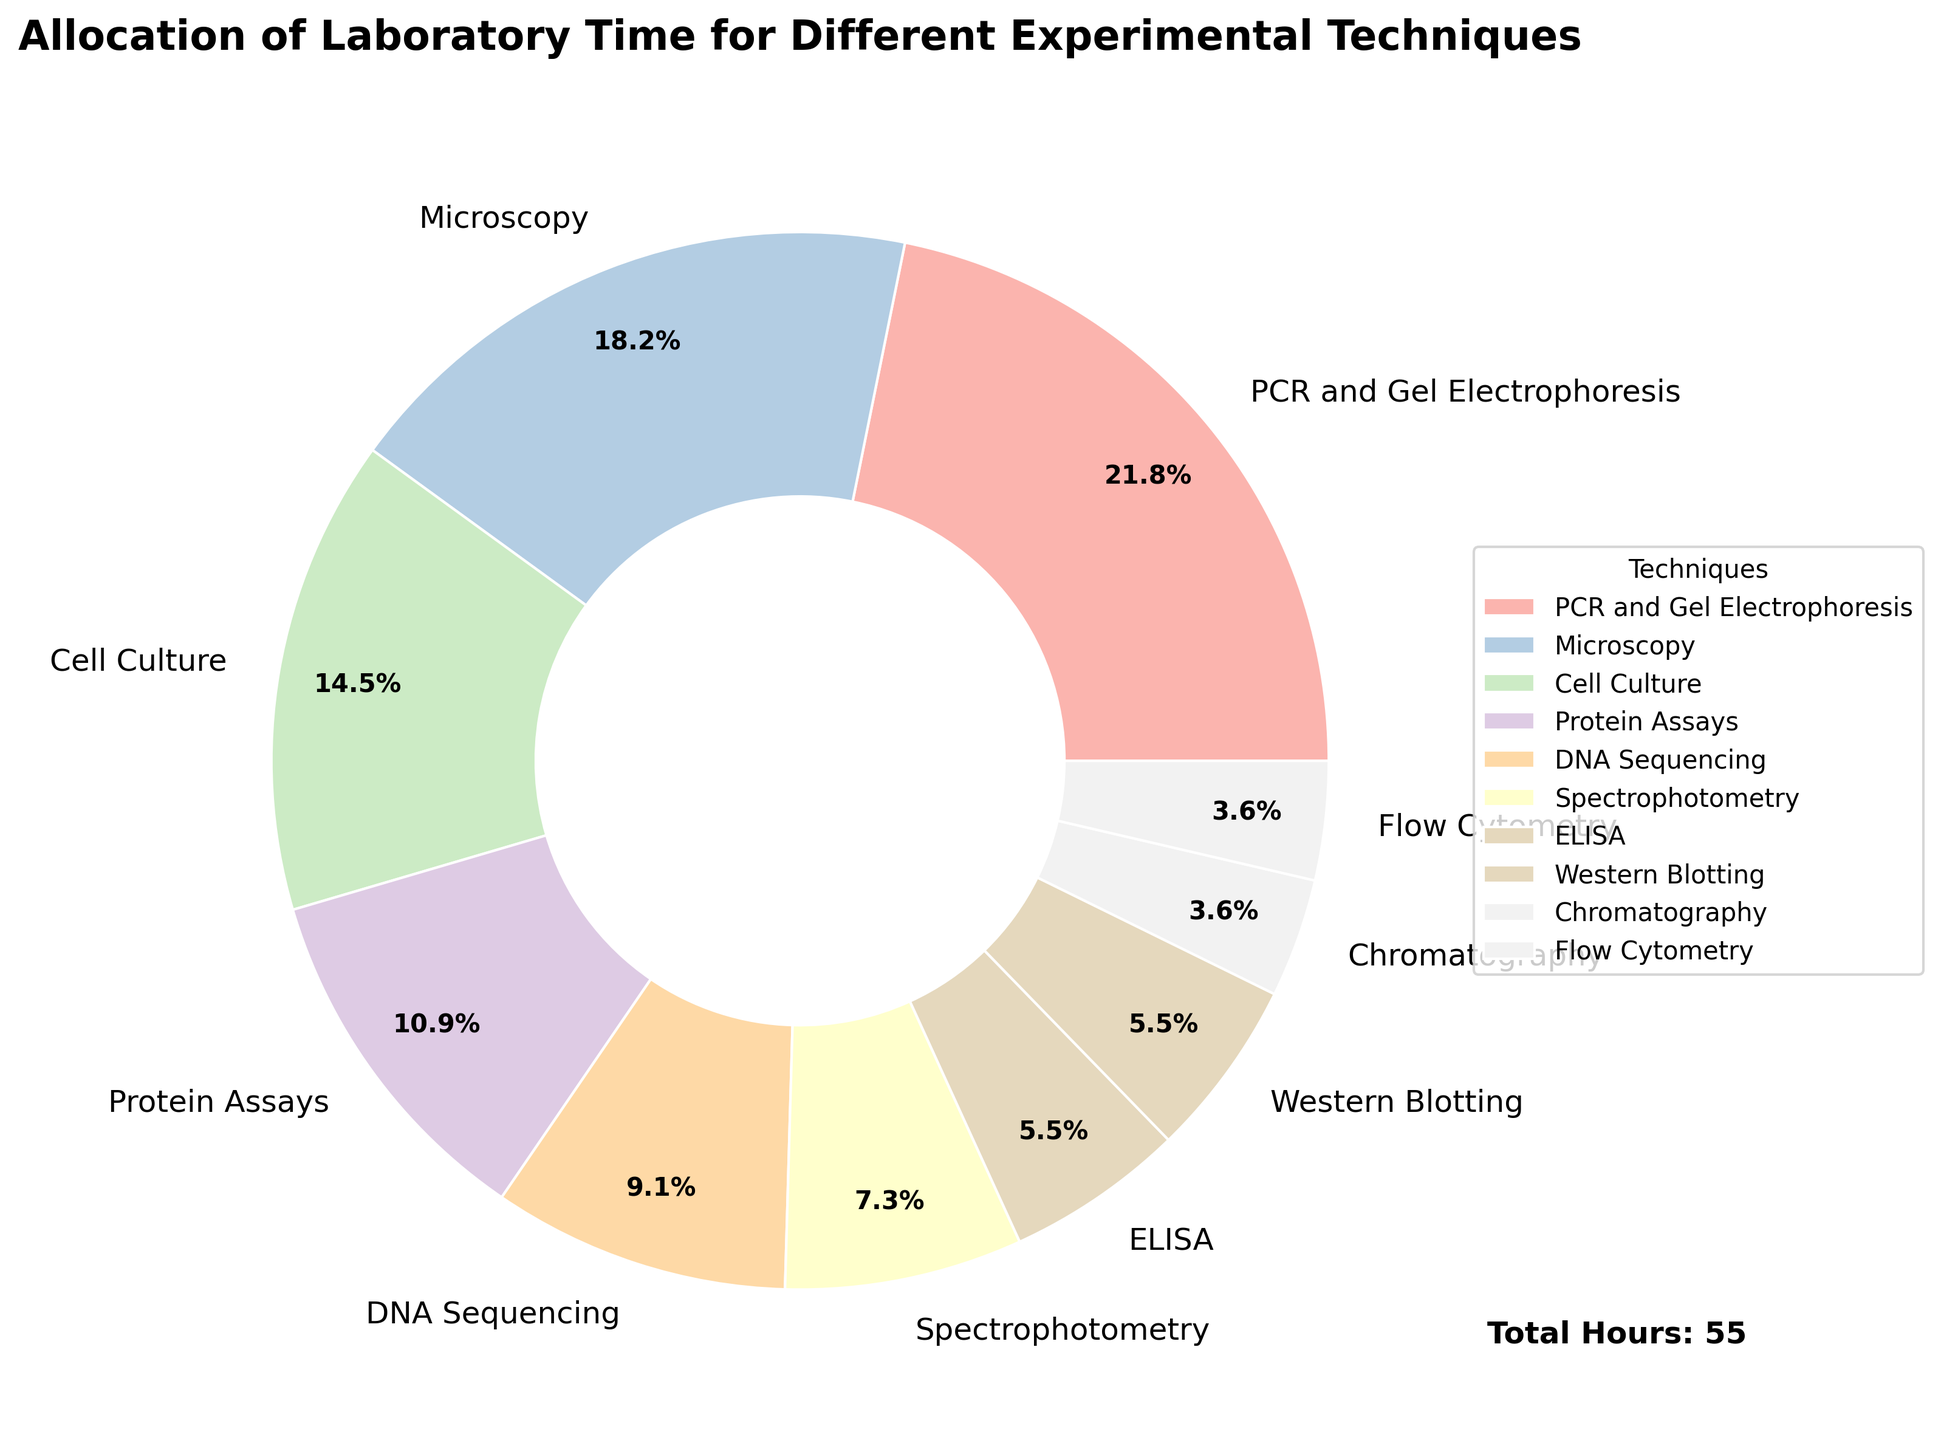Which technique is allocated the most laboratory hours? By examining the pie chart, it can be observed that the largest segment is labeled "PCR and Gel Electrophoresis" which visually appears to account for the highest number of hours.
Answer: PCR and Gel Electrophoresis Which technique is allocated the least laboratory hours? The smallest segment in the pie chart corresponds to the techniques "Chromatography" and "Flow Cytometry," each receiving a relatively thinner wedge.
Answer: Chromatography and Flow Cytometry How many more hours are allocated to Microscopy than to Spectrophotometry? There are 10 hours allocated to Microscopy and 4 hours to Spectrophotometry. The difference can be calculated by subtracting 4 from 10.
Answer: 6 Does Cell Culture receive more laboratory hours than DNA Sequencing and ELISA combined? Cell Culture is allocated 8 hours. DNA Sequencing has 5 hours, and ELISA has 3 hours. Combining the hours for DNA Sequencing and ELISA gives us 5 + 3 = 8 hours, which is equal to the hours for Cell Culture.
Answer: No What percentage of total laboratory hours is allocated to Protein Assays and Microscopy combined? Protein Assays have 6 hours and Microscopy has 10 hours. Combined, they have 6 + 10 = 16 hours. If we calculate the percentage of the total (which is 55 hours), we have (16/55) * 100 ≈ 29.1%.
Answer: 29.1% Compare the laboratory hours allocated to Western Blotting and ELISA. Which one has more hours? By examining the pie chart, Western Blotting is allocated 3 hours and ELISA is also allocated 3 hours, indicating they both have the same laboratory hours.
Answer: Equal What is the total percentage of laboratory hours allocated to DNA Sequencing and Spectrophotometry? DNA Sequencing is allocated 5 hours and Spectrophotometry is allocated 4 hours. Adding these gives 5 + 4 = 9 hours. The total hours are 55. Therefore, (9/55) * 100 ≈ 16.4% of total lab hours are allocated to these two techniques.
Answer: 16.4% How do the laboratory hours for Protein Assays compare to those for Cell Culture? The hours allocated to Protein Assays are 6, and for Cell Culture, it is 8. Comparing the two, Cell Culture has more hours than Protein Assays.
Answer: Cell Culture has more What is the second most allocated technique in terms of laboratory hours? After examining the chart, the technique with the largest allocation is "PCR and Gel Electrophoresis." The second largest segment belongs to "Microscopy."
Answer: Microscopy 